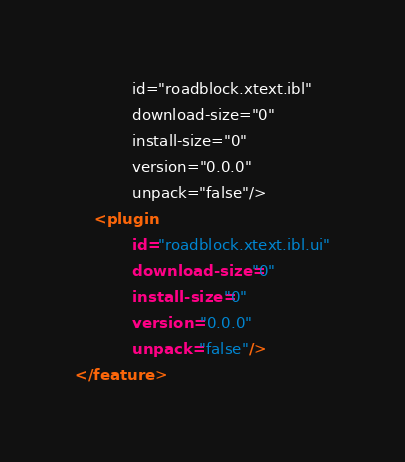Convert code to text. <code><loc_0><loc_0><loc_500><loc_500><_XML_>			id="roadblock.xtext.ibl"
			download-size="0"
			install-size="0"
			version="0.0.0"
			unpack="false"/>
	<plugin
			id="roadblock.xtext.ibl.ui"
			download-size="0"
			install-size="0"
			version="0.0.0"
			unpack="false"/>
</feature>
</code> 